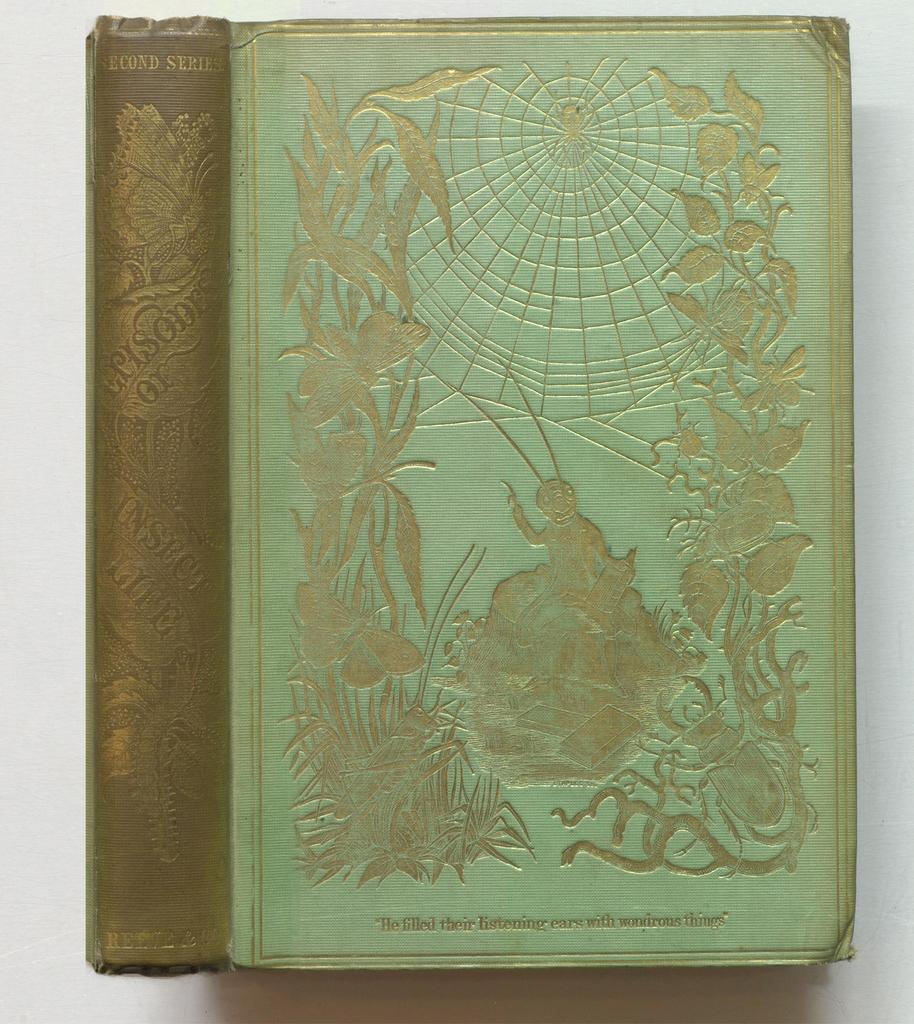What is the main subject of the image? There is a book in the center of the image. What can be found on the book? The book has text and some art on it. What color is the background of the image? The background of the image is white. What type of curtain is hanging in the background of the image? There is no curtain present in the image; the background is white. How does the fork interact with the book in the image? There is no fork present in the image; it only features a book with text and art. 